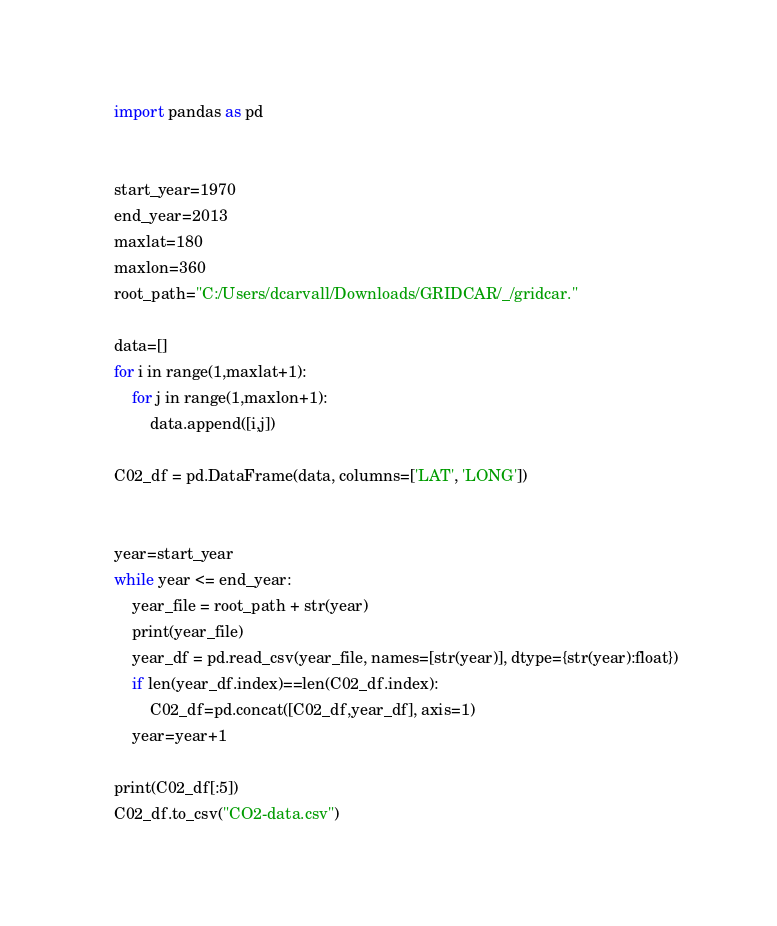Convert code to text. <code><loc_0><loc_0><loc_500><loc_500><_Python_>import pandas as pd


start_year=1970
end_year=2013
maxlat=180
maxlon=360
root_path="C:/Users/dcarvall/Downloads/GRIDCAR/_/gridcar."

data=[]
for i in range(1,maxlat+1):
    for j in range(1,maxlon+1):
        data.append([i,j])

C02_df = pd.DataFrame(data, columns=['LAT', 'LONG'])


year=start_year
while year <= end_year:
    year_file = root_path + str(year)
    print(year_file)
    year_df = pd.read_csv(year_file, names=[str(year)], dtype={str(year):float})
    if len(year_df.index)==len(C02_df.index):
        C02_df=pd.concat([C02_df,year_df], axis=1)
    year=year+1

print(C02_df[:5])
C02_df.to_csv("CO2-data.csv")</code> 